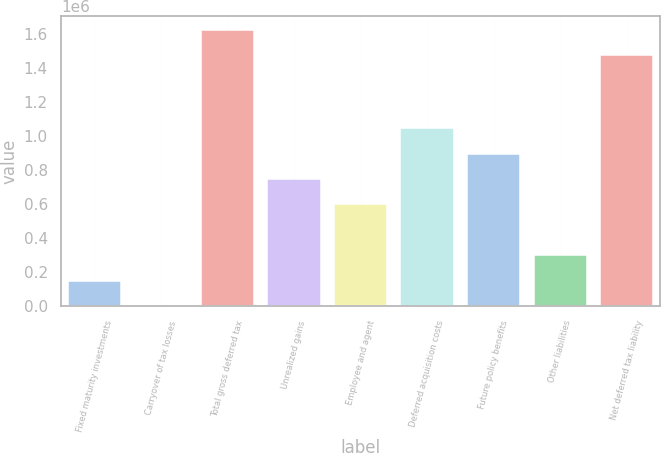Convert chart to OTSL. <chart><loc_0><loc_0><loc_500><loc_500><bar_chart><fcel>Fixed maturity investments<fcel>Carryover of tax losses<fcel>Total gross deferred tax<fcel>Unrealized gains<fcel>Employee and agent<fcel>Deferred acquisition costs<fcel>Future policy benefits<fcel>Other liabilities<fcel>Net deferred tax liability<nl><fcel>151214<fcel>2266<fcel>1.62232e+06<fcel>747004<fcel>598056<fcel>1.0449e+06<fcel>895951<fcel>300161<fcel>1.47338e+06<nl></chart> 